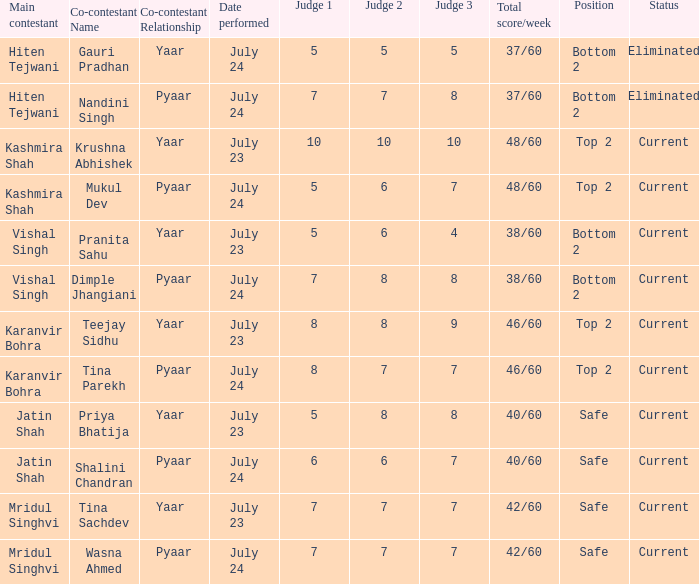Who is the main contestant with scores by each individual judge of 8 + 7 + 7 = 21? Karanvir Bohra. 